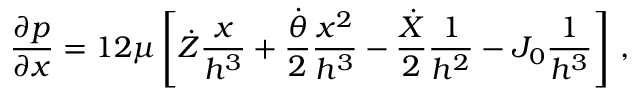Convert formula to latex. <formula><loc_0><loc_0><loc_500><loc_500>\frac { \partial p } { \partial x } = 1 2 \mu \left [ \dot { Z } \frac { x } { h ^ { 3 } } + \frac { \dot { \theta } } { 2 } \frac { x ^ { 2 } } { h ^ { 3 } } - \frac { \dot { X } } { 2 } \frac { 1 } { h ^ { 2 } } - J _ { 0 } \frac { 1 } { h ^ { 3 } } \right ] \, ,</formula> 